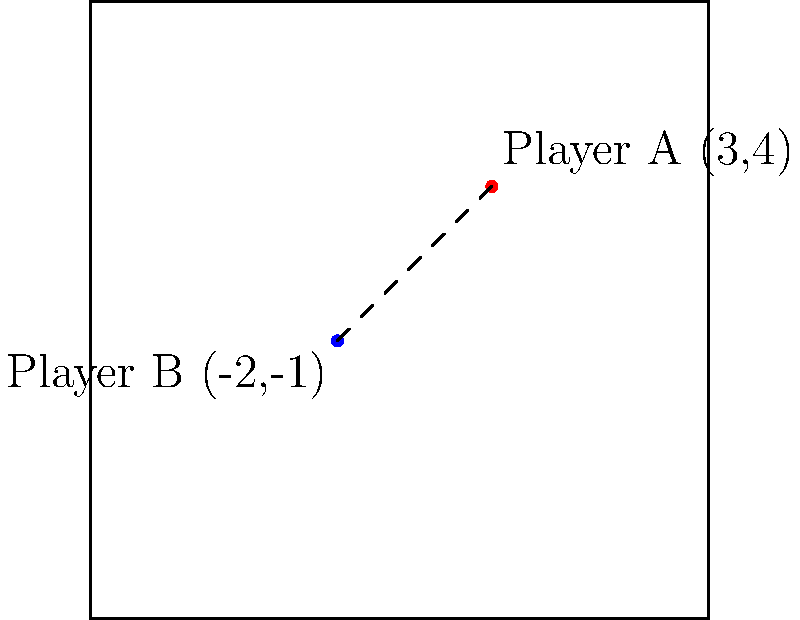During a game analysis, you notice two players' positions on the court represented by coordinates. Player A is at (3,4) and Player B is at (-2,-1). Calculate the distance between these two players using the distance formula derived from the Pythagorean theorem. To calculate the distance between two points in a coordinate plane, we use the distance formula:

$$ d = \sqrt{(x_2 - x_1)^2 + (y_2 - y_1)^2} $$

Where $(x_1, y_1)$ represents the coordinates of the first point and $(x_2, y_2)$ represents the coordinates of the second point.

Given:
Player A: $(x_1, y_1) = (3, 4)$
Player B: $(x_2, y_2) = (-2, -1)$

Let's substitute these values into the formula:

$$ d = \sqrt{(-2 - 3)^2 + (-1 - 4)^2} $$

Now, let's solve step-by-step:

1) Simplify the expressions inside the parentheses:
   $$ d = \sqrt{(-5)^2 + (-5)^2} $$

2) Calculate the squares:
   $$ d = \sqrt{25 + 25} $$

3) Add the terms under the square root:
   $$ d = \sqrt{50} $$

4) Simplify the square root:
   $$ d = 5\sqrt{2} $$

Therefore, the distance between Player A and Player B is $5\sqrt{2}$ units.
Answer: $5\sqrt{2}$ units 